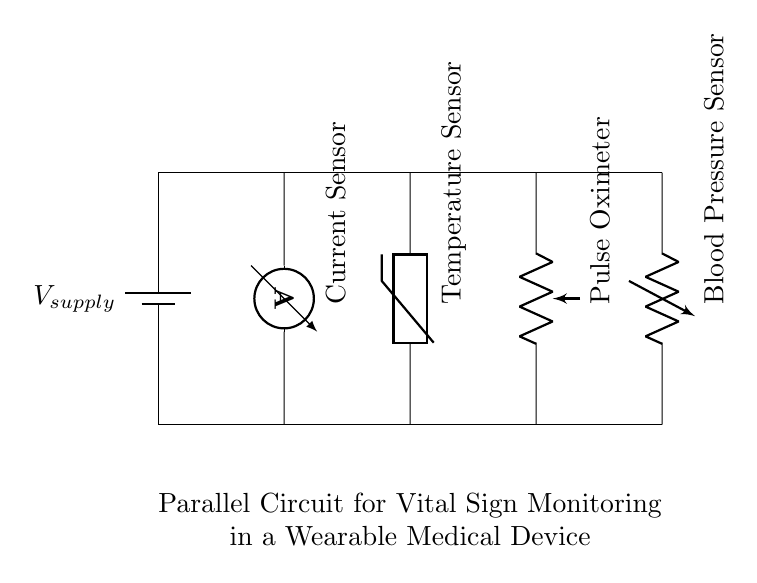What kind of sensors are used in this circuit? The circuit diagram shows four types of sensors: a current sensor, a temperature sensor, a pulse oximeter, and a blood pressure sensor, all connected in parallel.
Answer: current sensor, temperature sensor, pulse oximeter, blood pressure sensor What is the configuration of the circuit? The circuit is a parallel configuration, as indicated by the multiple branches extending from the supply voltage, allowing each sensor to operate independently while sharing the same voltage source.
Answer: parallel How many sensors are present in the circuit? The diagram depicts four sensors total: one current sensor, one temperature sensor, one pulse oximeter, and one blood pressure sensor.
Answer: four What is the role of the ammeter in the circuit? The ammeter measures the current flowing through the circuit, providing feedback on the flow of electricity to the sensors to monitor performance or detect issues.
Answer: current measurement How does the parallel arrangement affect sensor performance? In a parallel circuit, each sensor receives the same voltage, allowing them to operate independently, which can ensure that the failure of one sensor does not affect the others.
Answer: independent operation What is the supply voltage’s relationship to the sensors? The supply voltage provides power to all sensors in the circuit equally, allowing them to function simultaneously at the same voltage level, which enhances real-time monitoring capabilities.
Answer: equal voltage supply 